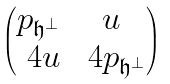Convert formula to latex. <formula><loc_0><loc_0><loc_500><loc_500>\begin{pmatrix} p _ { \mathfrak { h } ^ { \bot } } & u \\ \ 4 { u } & \ 4 { p _ { \mathfrak { h } ^ { \bot } } } \end{pmatrix}</formula> 